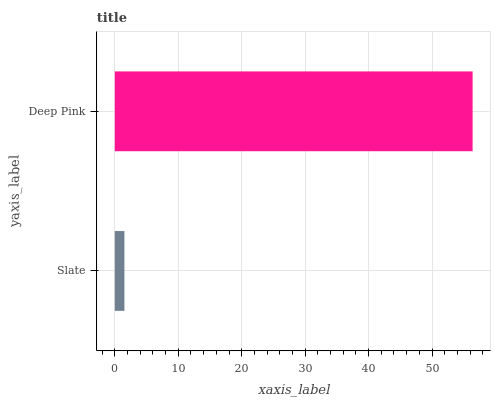Is Slate the minimum?
Answer yes or no. Yes. Is Deep Pink the maximum?
Answer yes or no. Yes. Is Deep Pink the minimum?
Answer yes or no. No. Is Deep Pink greater than Slate?
Answer yes or no. Yes. Is Slate less than Deep Pink?
Answer yes or no. Yes. Is Slate greater than Deep Pink?
Answer yes or no. No. Is Deep Pink less than Slate?
Answer yes or no. No. Is Deep Pink the high median?
Answer yes or no. Yes. Is Slate the low median?
Answer yes or no. Yes. Is Slate the high median?
Answer yes or no. No. Is Deep Pink the low median?
Answer yes or no. No. 